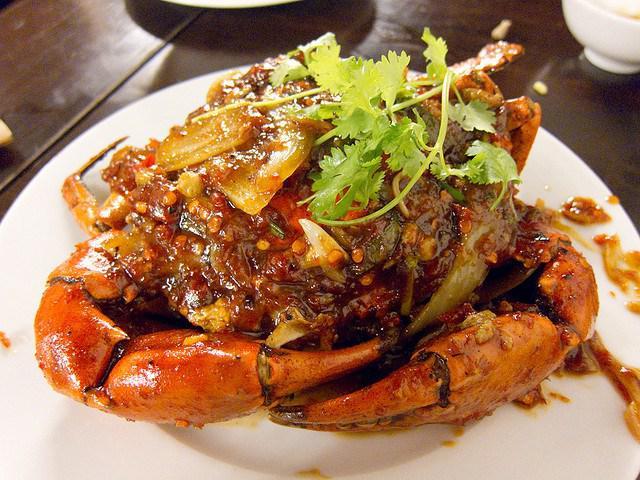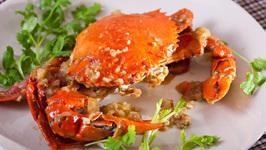The first image is the image on the left, the second image is the image on the right. Analyze the images presented: Is the assertion "The right image features a round plate containing one rightside-up crab with its red-orange shell and claws intact." valid? Answer yes or no. Yes. The first image is the image on the left, the second image is the image on the right. Analyze the images presented: Is the assertion "IN at least one image there is a dead and full crab with it head intact sitting on a white plate." valid? Answer yes or no. Yes. 